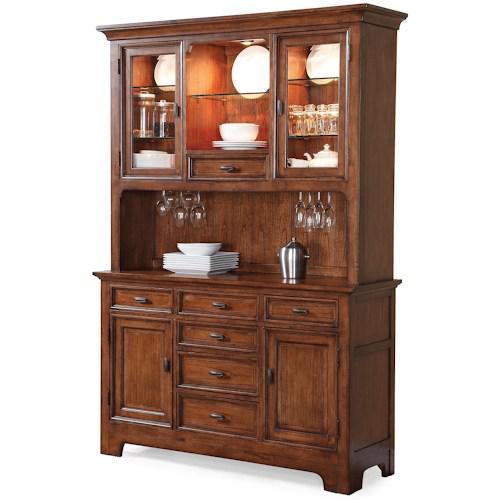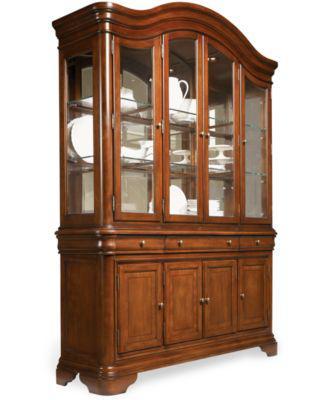The first image is the image on the left, the second image is the image on the right. Examine the images to the left and right. Is the description "A wooden hutch in one image has a middle open section with three glass doors above, and a section with drawers and solid panel doors below." accurate? Answer yes or no. Yes. The first image is the image on the left, the second image is the image on the right. For the images shown, is this caption "One of the cabinets has an arched, curved top, and both cabinets have some type of feet." true? Answer yes or no. Yes. 